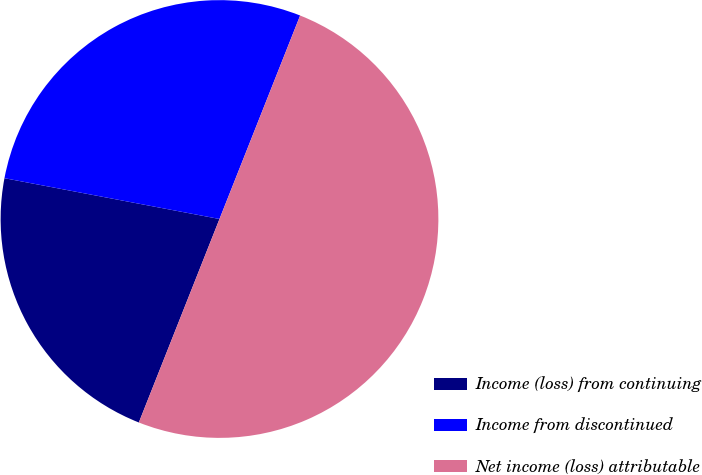<chart> <loc_0><loc_0><loc_500><loc_500><pie_chart><fcel>Income (loss) from continuing<fcel>Income from discontinued<fcel>Net income (loss) attributable<nl><fcel>21.98%<fcel>28.02%<fcel>50.0%<nl></chart> 